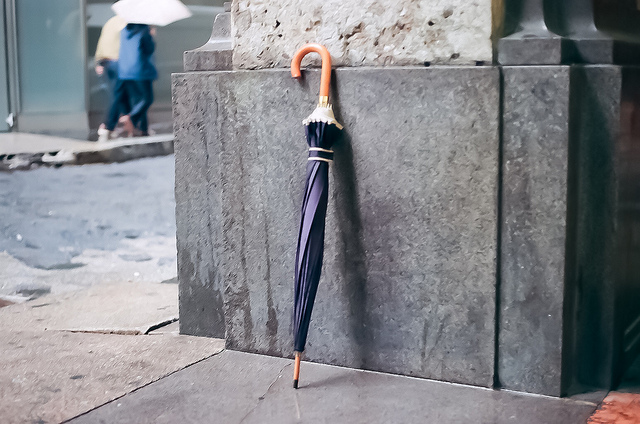Is this area crowded? No, the area is not crowded. There is only one person visible in the distance, suggesting this might be a quieter street or a less busy time of day. 